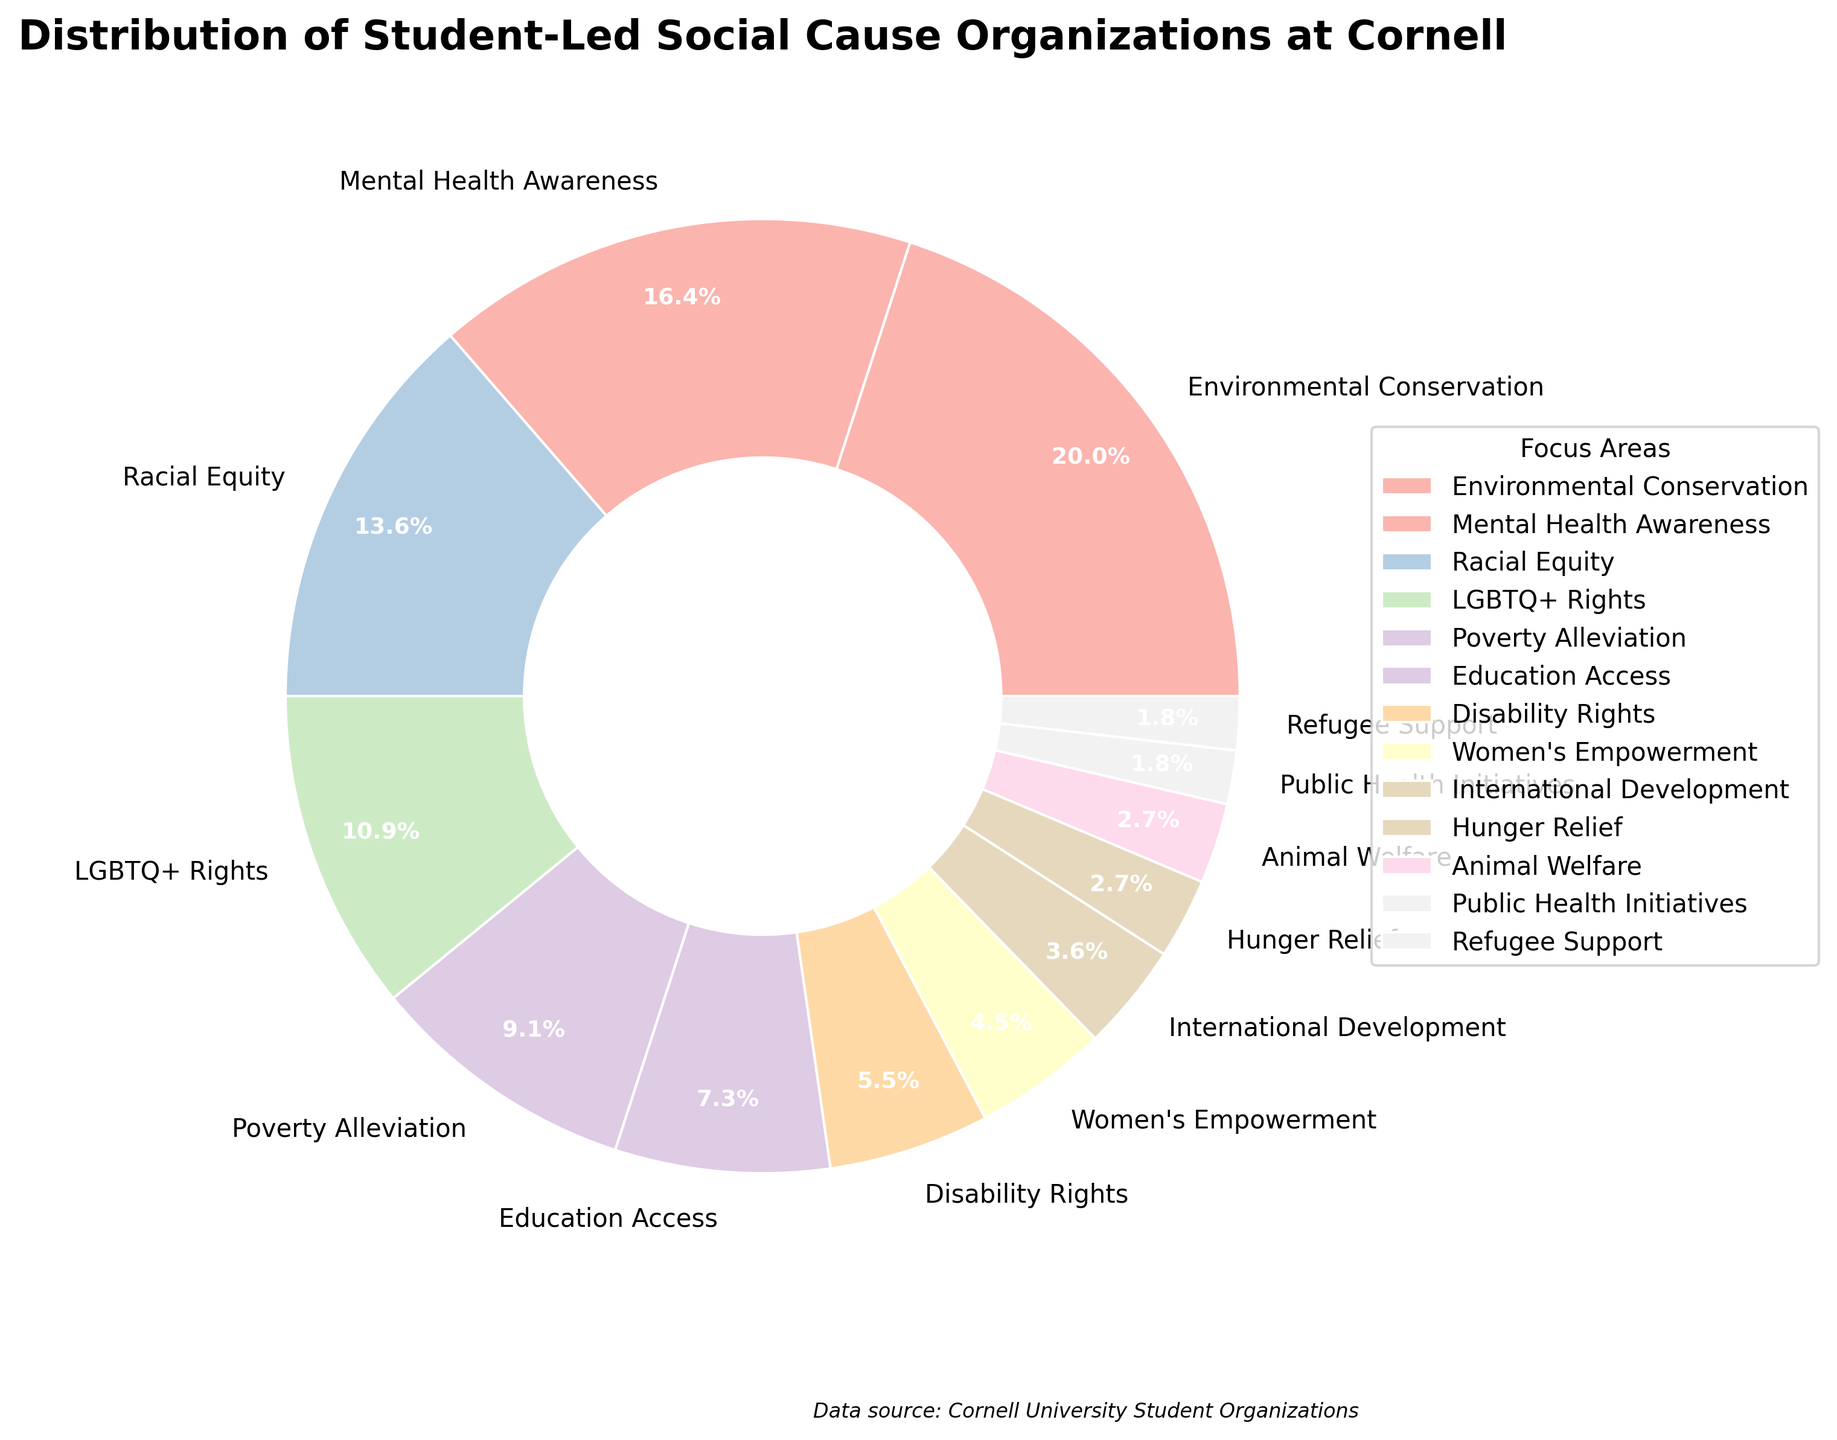What percentage of student-led organizations focus on Environmental Conservation? Observe the figures next to the segment labeled "Environmental Conservation" in the pie chart. The figure reads 22%.
Answer: 22% Which focus area has the smallest percentage of student-led organizations? Identify the smallest segment in the pie chart and read its label. The smallest is "Public Health Initiatives" which is 2%.
Answer: Public Health Initiatives How does the percentage of organizations focused on Mental Health Awareness compare to those focused on Racial Equity? Find the segments labeled "Mental Health Awareness" and "Racial Equity" and compare their percentages. Mental Health Awareness is 18%, and Racial Equity is 15%, so Mental Health Awareness has a higher percentage.
Answer: Mental Health Awareness What is the combined percentage of organizations that focus on Women’s Empowerment and Refugee Support? Find the segments for "Women's Empowerment" (5%) and "Refugee Support" (2%) and sum them. 5% + 2% is 7%.
Answer: 7% Is the percentage of organizations focused on Poverty Alleviation greater than those focused on Hunger Relief? Compare the percentages next to the segments for "Poverty Alleviation" (10%) and "Hunger Relief" (3%). Poverty Alleviation is greater.
Answer: Yes Which three focus areas have the highest percentages? Identify and list the three largest segments in the pie chart. The largest segments are "Environmental Conservation" (22%), "Mental Health Awareness" (18%), and "Racial Equity" (15%).
Answer: Environmental Conservation, Mental Health Awareness, Racial Equity Between LGBTQ+ Rights and Disability Rights, which has a higher percentage and by how much? Compare the segments labeled "LGBTQ+ Rights" (12%) and "Disability Rights" (6%) and find the difference. 12% - 6% is 6%.
Answer: LGBTQ+ Rights by 6% What is the total percentage of organizations focused on International Development, Animal Welfare, and Hunger Relief? Find the percentages for "International Development" (4%), "Animal Welfare" (3%), and "Hunger Relief" (3%), then sum them. 4% + 3% + 3% is 10%.
Answer: 10% Which focus area is represented by a light green color? Look at the color assigned to each segment and match it with the corresponding label. The light green color represents "Mental Health Awareness".
Answer: Mental Health Awareness 